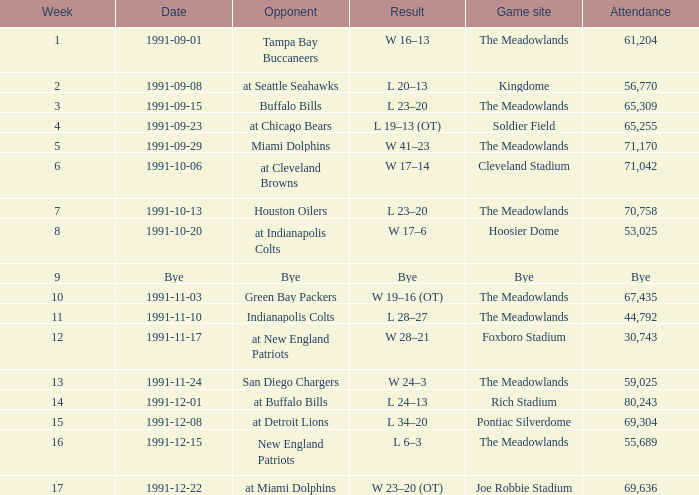In the event that took place on 13th october 1991, which opponent was present? Houston Oilers. 